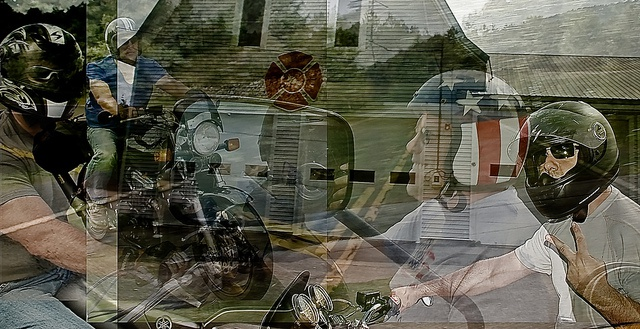Describe the objects in this image and their specific colors. I can see people in black, darkgray, and gray tones, people in black, darkgray, and gray tones, people in black, gray, and darkgreen tones, motorcycle in black, gray, darkgray, and darkgreen tones, and motorcycle in black, gray, darkgreen, and darkgray tones in this image. 